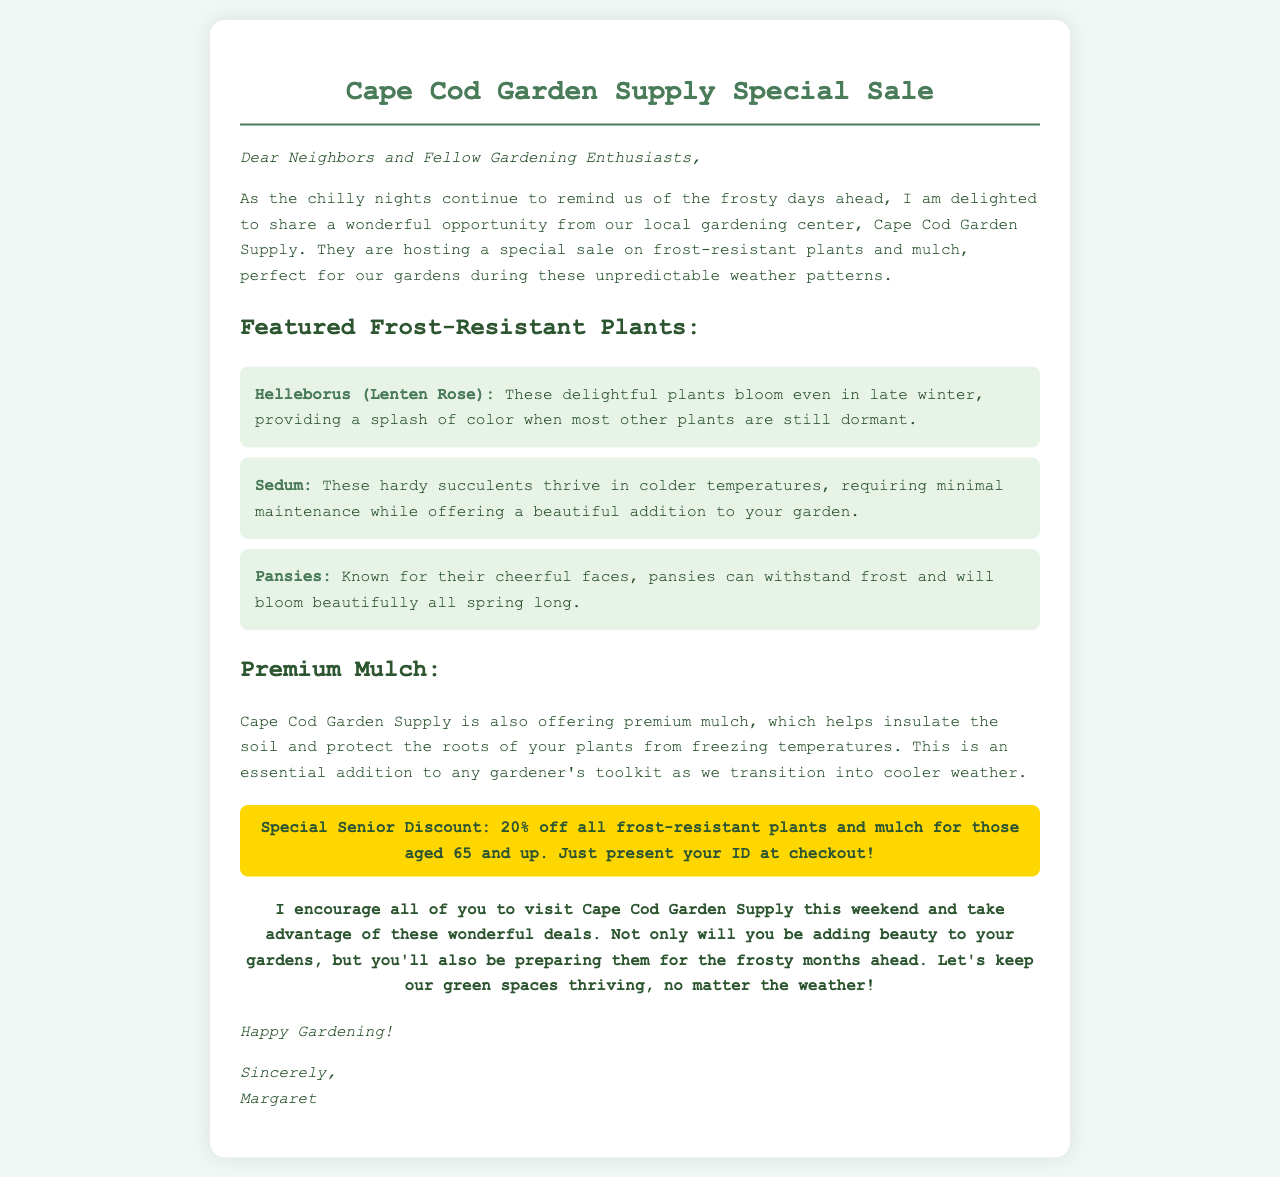what is the name of the gardening center? The gardening center is named Cape Cod Garden Supply.
Answer: Cape Cod Garden Supply what is the special discount for seniors? The special discount is 20% off all frost-resistant plants and mulch for those aged 65 and up.
Answer: 20% off what type of plants are featured in the sale? The featured plants are frost-resistant plants.
Answer: frost-resistant plants how can seniors avail of the discount? Seniors can avail of the discount by presenting their ID at checkout.
Answer: presenting your ID what is the purpose of using premium mulch? Premium mulch helps insulate the soil and protect the roots of plants from freezing temperatures.
Answer: insulate the soil which frost-resistant plant blooms in late winter? The plant that blooms in late winter is Helleborus (Lenten Rose).
Answer: Helleborus (Lenten Rose) how does the letter sign off? The letter closes with "Happy Gardening!"
Answer: Happy Gardening! what is the main encouragement offered in the letter? The main encouragement is to visit Cape Cod Garden Supply this weekend.
Answer: visit Cape Cod Garden Supply this weekend 